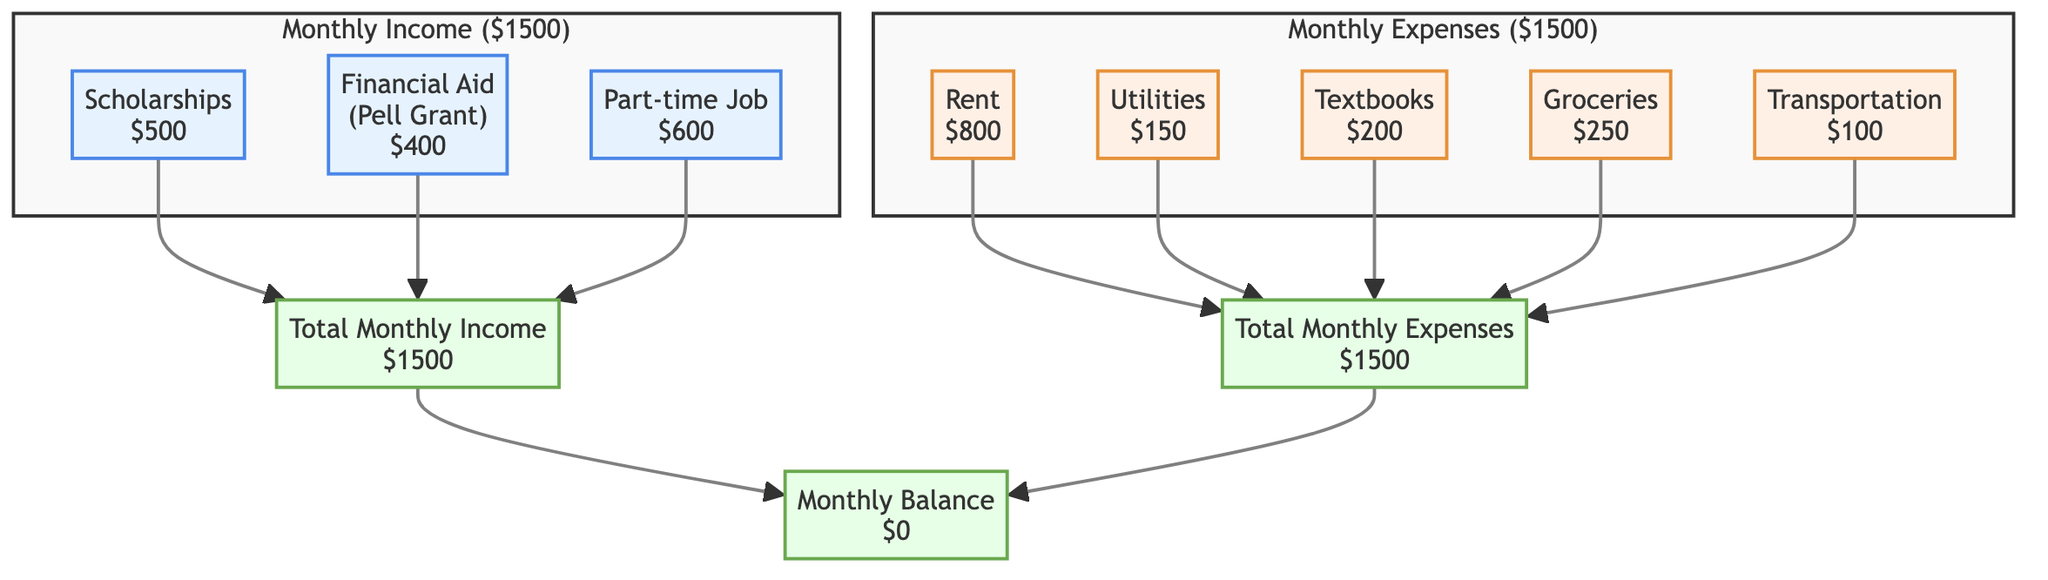What is the total monthly income? The diagram indicates that the total monthly income is at the bottom of the income section, labeled as "Total Monthly Income" with a value of $1500.
Answer: $1500 How much are the scholarships? The scholarship amount is listed in the income section directly under "Scholarships," indicating it is $500.
Answer: $500 What is the total amount spent on textbooks? The amount for textbooks is explicitly shown under the expenses section labeled as "Textbooks" with a value of $200.
Answer: $200 What is the difference between total income and total expenses? The total monthly income is $1500 and the total monthly expenses are also $1500. Subtracting these amounts gives a balance of $0.
Answer: $0 How many sources of income are listed? In the income section, there are three sources listed: Scholarships, Financial Aid, and Part-time Job. Counting these gives a total of 3 sources.
Answer: 3 What is the highest expense listed? The expense section shows "Rent" at $800, which is the highest amount compared to the other expenses outlined in the chart.
Answer: Rent How much is spent on utilities? The amount for utilities is shown directly under "Utilities" in the expenses section, which indicates it is $150.
Answer: $150 Which is the only net balance shown? The net balance after income and expenses is displayed as "Monthly Balance" at the bottom of the chart, which is $0, indicating no surplus or deficit.
Answer: $0 What is the total spent on living costs (Rent, Utilities, and Groceries)? To find living costs, add Rent ($800), Utilities ($150), and Groceries ($250), which totals $1200.
Answer: $1200 